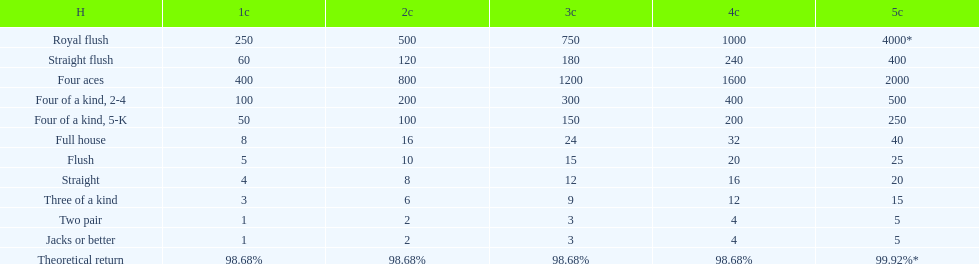Is a 2 credit full house the same as a 5 credit three of a kind? No. 